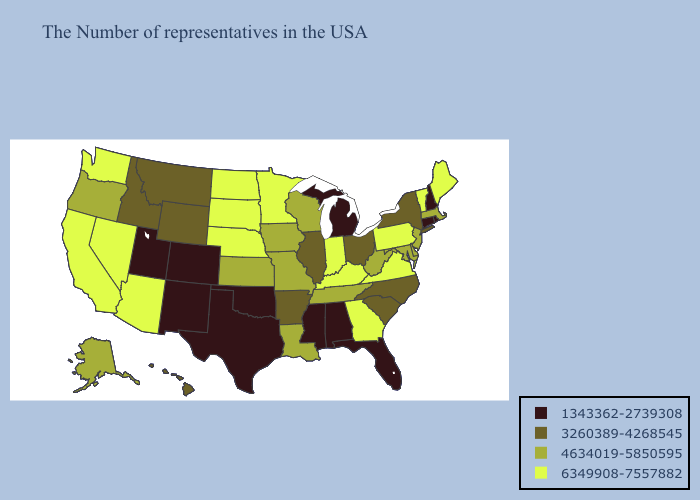Among the states that border Virginia , does Kentucky have the highest value?
Concise answer only. Yes. Does Minnesota have the lowest value in the USA?
Short answer required. No. Among the states that border Kentucky , does Tennessee have the highest value?
Concise answer only. No. Name the states that have a value in the range 3260389-4268545?
Keep it brief. New York, North Carolina, South Carolina, Ohio, Illinois, Arkansas, Wyoming, Montana, Idaho, Hawaii. Name the states that have a value in the range 3260389-4268545?
Be succinct. New York, North Carolina, South Carolina, Ohio, Illinois, Arkansas, Wyoming, Montana, Idaho, Hawaii. Does Minnesota have the highest value in the MidWest?
Give a very brief answer. Yes. What is the value of Ohio?
Give a very brief answer. 3260389-4268545. Does Kentucky have the same value as Massachusetts?
Quick response, please. No. Which states have the lowest value in the USA?
Concise answer only. Rhode Island, New Hampshire, Connecticut, Florida, Michigan, Alabama, Mississippi, Oklahoma, Texas, Colorado, New Mexico, Utah. What is the value of South Carolina?
Keep it brief. 3260389-4268545. Name the states that have a value in the range 4634019-5850595?
Write a very short answer. Massachusetts, New Jersey, Delaware, Maryland, West Virginia, Tennessee, Wisconsin, Louisiana, Missouri, Iowa, Kansas, Oregon, Alaska. Does North Dakota have the same value as Michigan?
Short answer required. No. Name the states that have a value in the range 3260389-4268545?
Keep it brief. New York, North Carolina, South Carolina, Ohio, Illinois, Arkansas, Wyoming, Montana, Idaho, Hawaii. What is the lowest value in the MidWest?
Quick response, please. 1343362-2739308. Name the states that have a value in the range 6349908-7557882?
Concise answer only. Maine, Vermont, Pennsylvania, Virginia, Georgia, Kentucky, Indiana, Minnesota, Nebraska, South Dakota, North Dakota, Arizona, Nevada, California, Washington. 